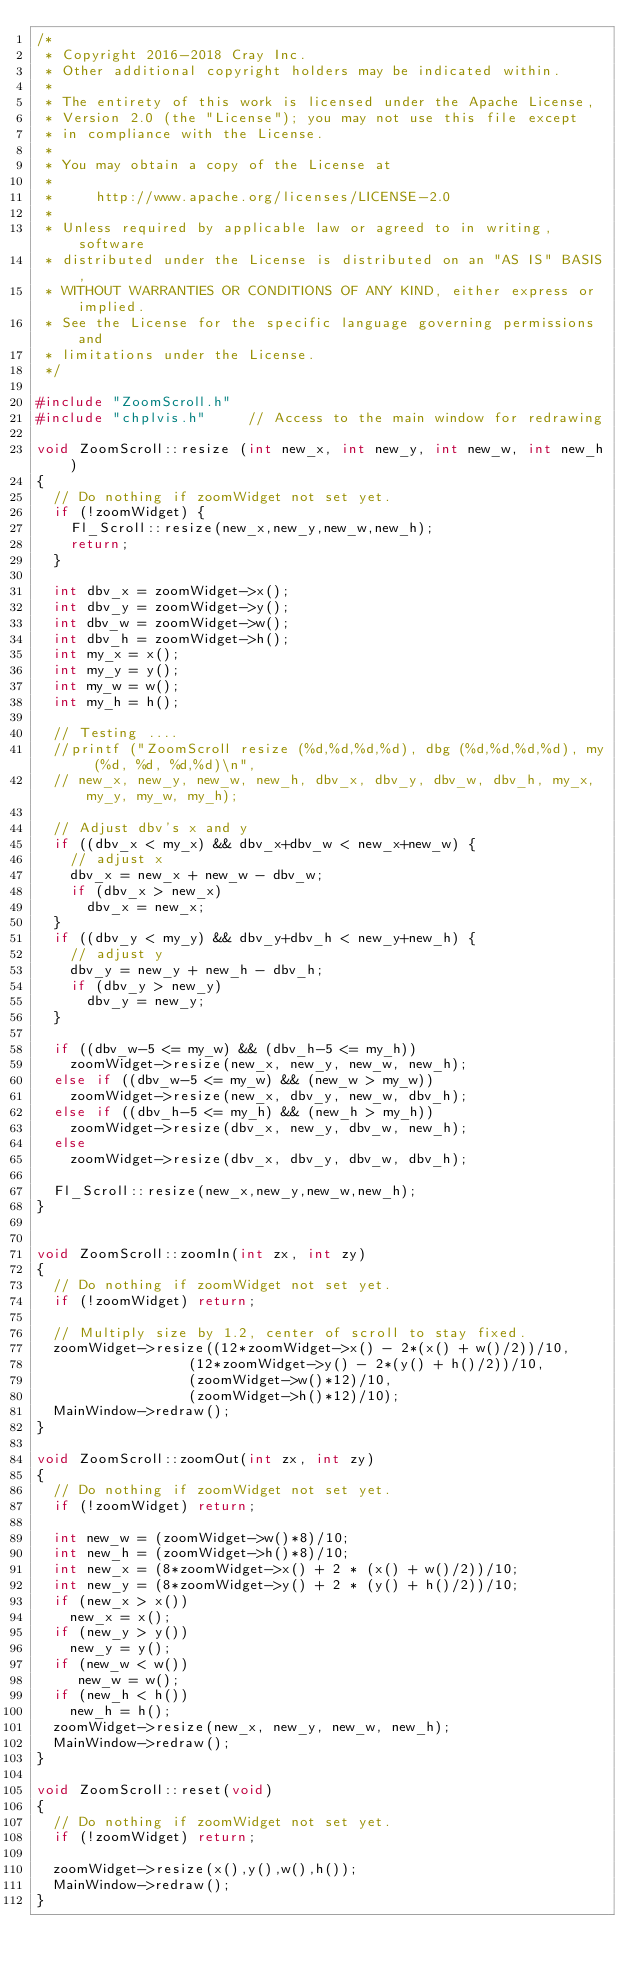Convert code to text. <code><loc_0><loc_0><loc_500><loc_500><_C++_>/*
 * Copyright 2016-2018 Cray Inc.
 * Other additional copyright holders may be indicated within.
 *
 * The entirety of this work is licensed under the Apache License,
 * Version 2.0 (the "License"); you may not use this file except
 * in compliance with the License.
 *
 * You may obtain a copy of the License at
 *
 *     http://www.apache.org/licenses/LICENSE-2.0
 *
 * Unless required by applicable law or agreed to in writing, software
 * distributed under the License is distributed on an "AS IS" BASIS,
 * WITHOUT WARRANTIES OR CONDITIONS OF ANY KIND, either express or implied.
 * See the License for the specific language governing permissions and
 * limitations under the License.
 */

#include "ZoomScroll.h"
#include "chplvis.h"     // Access to the main window for redrawing

void ZoomScroll::resize (int new_x, int new_y, int new_w, int new_h)
{
  // Do nothing if zoomWidget not set yet.
  if (!zoomWidget) {
    Fl_Scroll::resize(new_x,new_y,new_w,new_h);
    return;
  }
  
  int dbv_x = zoomWidget->x();
  int dbv_y = zoomWidget->y();
  int dbv_w = zoomWidget->w();
  int dbv_h = zoomWidget->h();
  int my_x = x();
  int my_y = y();
  int my_w = w();
  int my_h = h();

  // Testing ....
  //printf ("ZoomScroll resize (%d,%d,%d,%d), dbg (%d,%d,%d,%d), my (%d, %d, %d,%d)\n",
  // new_x, new_y, new_w, new_h, dbv_x, dbv_y, dbv_w, dbv_h, my_x, my_y, my_w, my_h);

  // Adjust dbv's x and y
  if ((dbv_x < my_x) && dbv_x+dbv_w < new_x+new_w) {
    // adjust x
    dbv_x = new_x + new_w - dbv_w;
    if (dbv_x > new_x)
      dbv_x = new_x;
  }
  if ((dbv_y < my_y) && dbv_y+dbv_h < new_y+new_h) {
    // adjust y
    dbv_y = new_y + new_h - dbv_h;
    if (dbv_y > new_y)
      dbv_y = new_y;
  }

  if ((dbv_w-5 <= my_w) && (dbv_h-5 <= my_h))
    zoomWidget->resize(new_x, new_y, new_w, new_h);
  else if ((dbv_w-5 <= my_w) && (new_w > my_w))
    zoomWidget->resize(new_x, dbv_y, new_w, dbv_h);
  else if ((dbv_h-5 <= my_h) && (new_h > my_h))
    zoomWidget->resize(dbv_x, new_y, dbv_w, new_h);
  else
    zoomWidget->resize(dbv_x, dbv_y, dbv_w, dbv_h);

  Fl_Scroll::resize(new_x,new_y,new_w,new_h);
}


void ZoomScroll::zoomIn(int zx, int zy)
{
  // Do nothing if zoomWidget not set yet.
  if (!zoomWidget) return;
  
  // Multiply size by 1.2, center of scroll to stay fixed.
  zoomWidget->resize((12*zoomWidget->x() - 2*(x() + w()/2))/10,
                  (12*zoomWidget->y() - 2*(y() + h()/2))/10,
                  (zoomWidget->w()*12)/10,
                  (zoomWidget->h()*12)/10);
  MainWindow->redraw();
}

void ZoomScroll::zoomOut(int zx, int zy)
{
  // Do nothing if zoomWidget not set yet.
  if (!zoomWidget) return;

  int new_w = (zoomWidget->w()*8)/10;
  int new_h = (zoomWidget->h()*8)/10;
  int new_x = (8*zoomWidget->x() + 2 * (x() + w()/2))/10;
  int new_y = (8*zoomWidget->y() + 2 * (y() + h()/2))/10;
  if (new_x > x())
    new_x = x();
  if (new_y > y())
    new_y = y();
  if (new_w < w())
     new_w = w();
  if (new_h < h())
    new_h = h();
  zoomWidget->resize(new_x, new_y, new_w, new_h);
  MainWindow->redraw();
}

void ZoomScroll::reset(void)
{
  // Do nothing if zoomWidget not set yet.
  if (!zoomWidget) return;

  zoomWidget->resize(x(),y(),w(),h());
  MainWindow->redraw();
}
</code> 